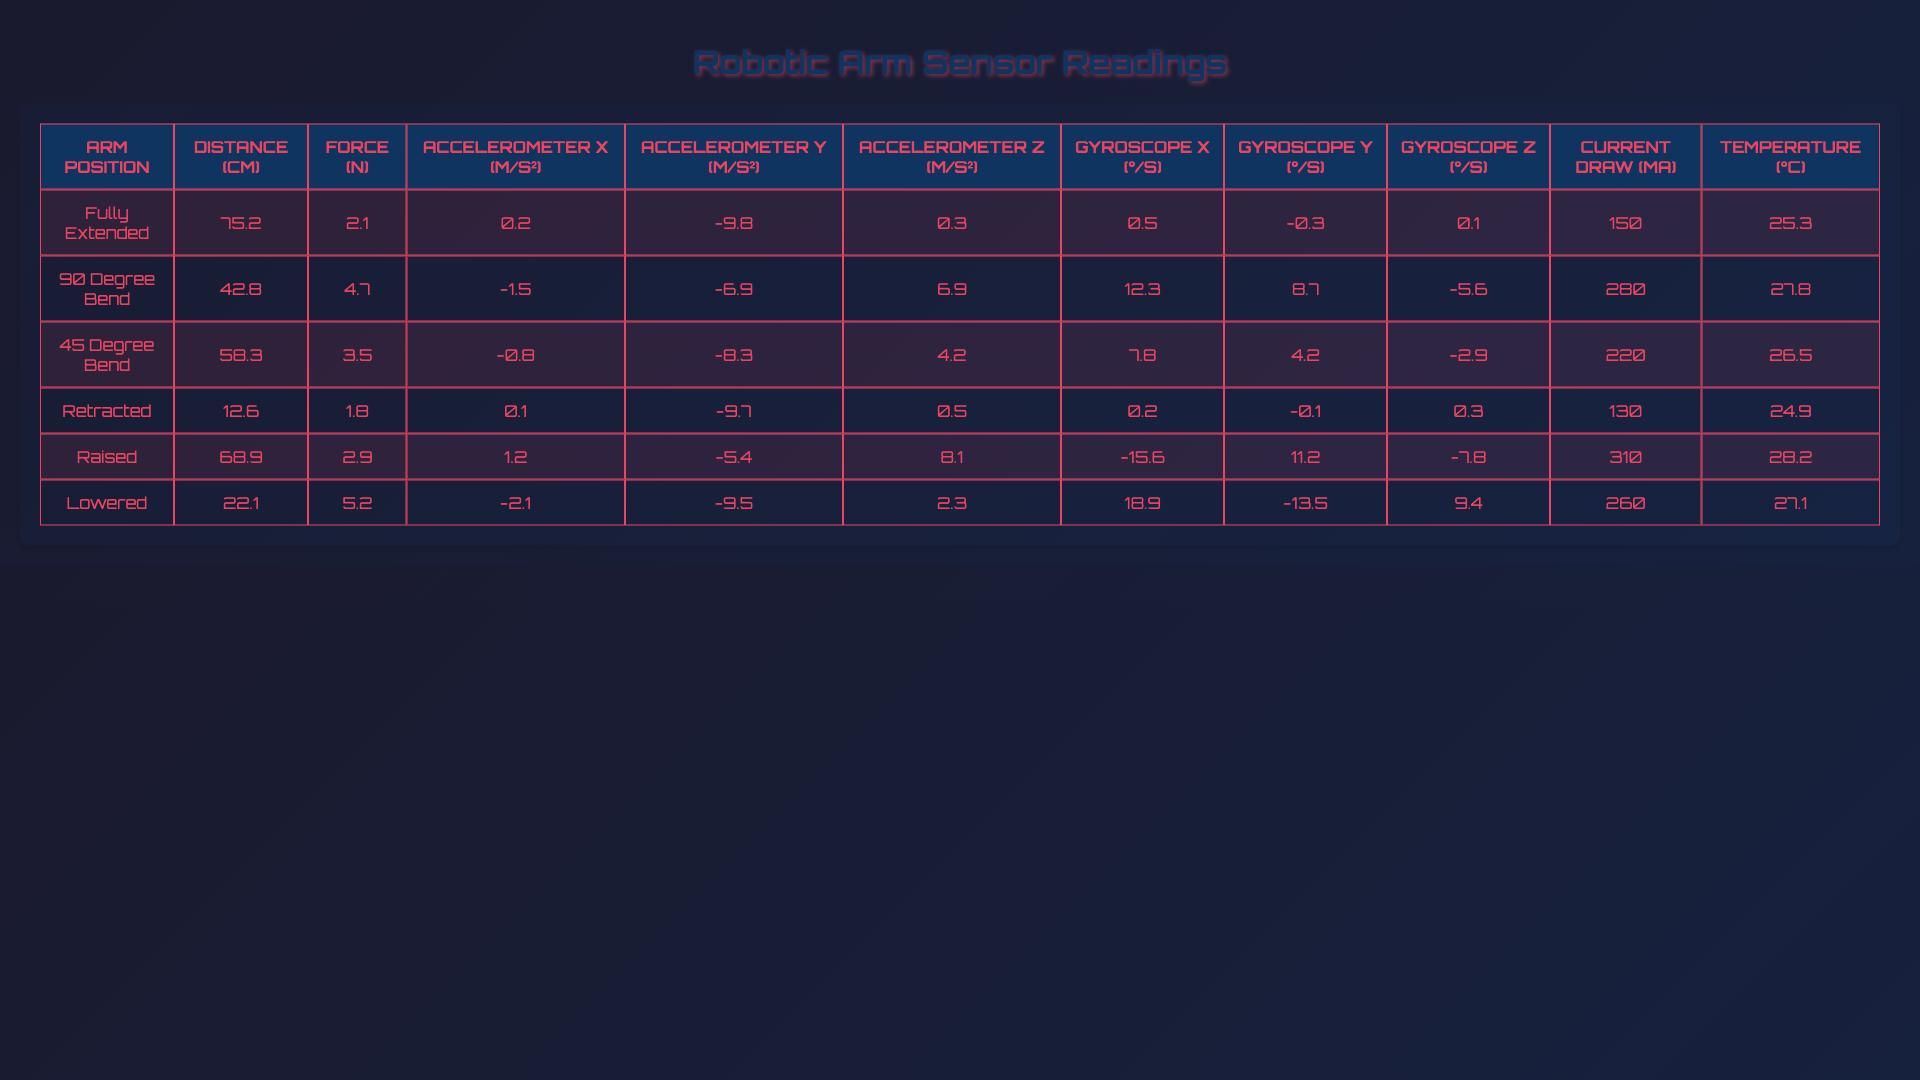What is the distance measured at the "Fully Extended" arm position? The table shows that the distance sensor reading for the "Fully Extended" position is 75.2 cm.
Answer: 75.2 cm Which arm position has the highest force reading? By checking the force sensor readings in the table, the highest value is 5.2 N at the "Lowered" arm position.
Answer: Lowered What is the average distance reading across all arm positions? The distance readings for all arm positions are: 75.2, 42.8, 58.3, 12.6, 68.9, and 22.1 cm. Adding these gives 279.9 cm. Dividing by 6 gives an average distance of 46.65 cm.
Answer: 46.65 cm Is the current draw highest when the arm is "Raised"? The current draw for the "Raised" position is 310 mA, which is higher than the other positions. Thus, this statement is true.
Answer: Yes What is the difference in force readings between "Retracted" and "90 Degree Bend"? The force reading for "Retracted" is 1.8 N and for "90 Degree Bend" it is 4.7 N. The difference is 4.7 - 1.8 = 2.9 N.
Answer: 2.9 N What is the lowest temperature reading recorded in the table? Scanning the temperature readings, the lowest value is 24.9°C at the "Retracted" position.
Answer: 24.9°C What is the sum of the accelerometer X readings for all arm positions? The accelerometer X readings are 0.2, -1.5, -0.8, 0.1, 1.2, and -2.1 m/s². Adding these together gives a sum of -3.0 m/s².
Answer: -3.0 m/s² Which arm position has the most extreme gyroscope Z reading? The gyroscope Z readings are: 0.1, -5.6, -2.9, 0.3, -7.8, and 9.4 dps. The most extreme value, in terms of absolute value, is 9.4 dps for the "Lowered" position.
Answer: Lowered Find the average accelerometer Y reading across all positions. The accelerometer Y readings are: -9.8, -6.9, -8.3, -9.7, -5.4, and -9.5 m/s². The sum is -49.6 m/s², and dividing by 6 gives an average of -8.27 m/s².
Answer: -8.27 m/s² Is the distance reading closer to 60 cm when the arm is "Lowered"? The distance reading for "Lowered" is 22.1 cm, which is not close to 60 cm. Thus, this statement is false.
Answer: No What is the relationship between the current draw and the temperature for each arm position? After comparing the current draw and temperature values, it can be noted that as the current increases (e.g., 310 mA at "Raised"), the temperature tends to be higher (e.g., 28.2°C), indicating a possible positive correlation.
Answer: Positive correlation 